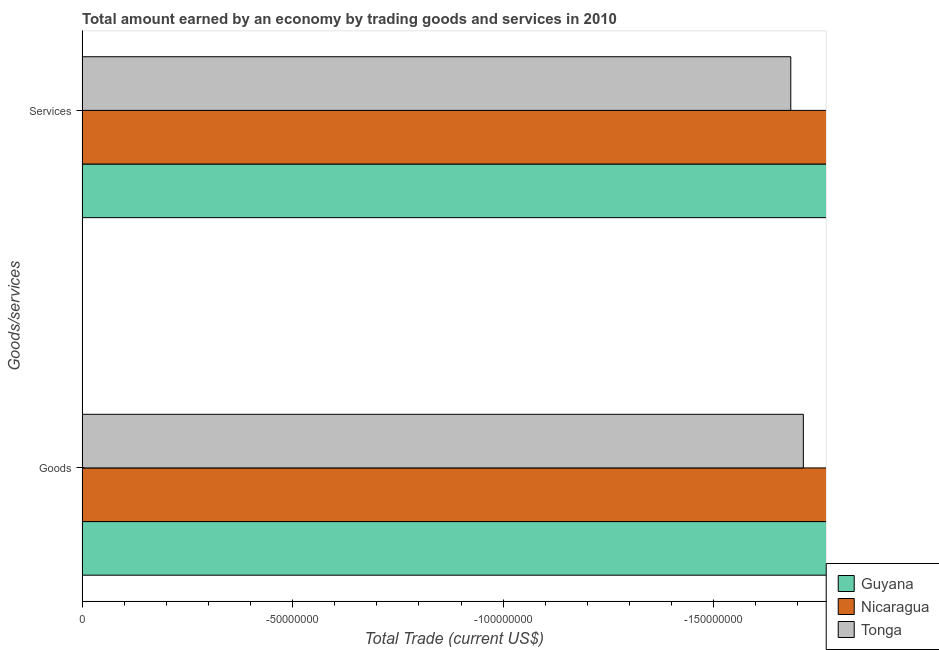How many different coloured bars are there?
Provide a succinct answer. 0. How many bars are there on the 1st tick from the bottom?
Keep it short and to the point. 0. What is the label of the 1st group of bars from the top?
Offer a terse response. Services. What is the average amount earned by trading services per country?
Provide a short and direct response. 0. Are all the bars in the graph horizontal?
Provide a short and direct response. Yes. Does the graph contain any zero values?
Offer a terse response. Yes. Does the graph contain grids?
Your response must be concise. No. How are the legend labels stacked?
Provide a succinct answer. Vertical. What is the title of the graph?
Provide a short and direct response. Total amount earned by an economy by trading goods and services in 2010. What is the label or title of the X-axis?
Provide a succinct answer. Total Trade (current US$). What is the label or title of the Y-axis?
Make the answer very short. Goods/services. What is the Total Trade (current US$) of Guyana in Goods?
Offer a very short reply. 0. What is the average Total Trade (current US$) of Nicaragua per Goods/services?
Your answer should be very brief. 0. 